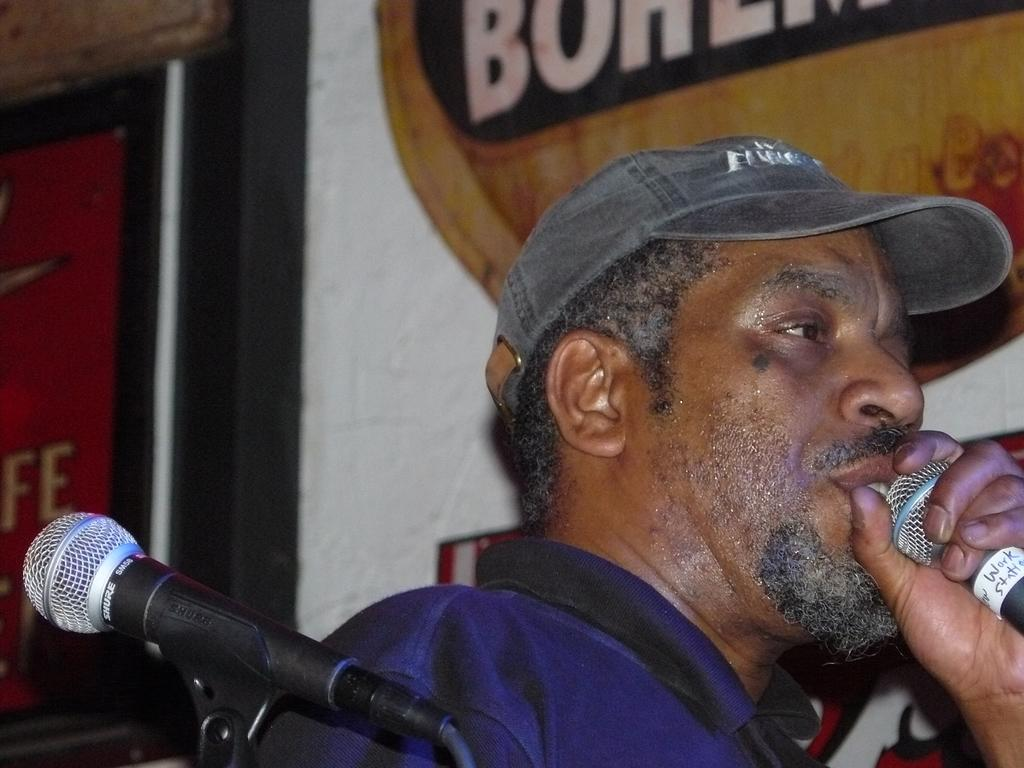Who is present in the image? There is a person in the image. What is the person holding in the image? The person is holding a microphone. What type of headwear is the person wearing? The person is wearing a cap. Can you describe the microphone's location in the image? There is a microphone in the left bottom of the image. What else can be seen in the image besides the person and the microphone? There is a banner in the image. What is visible in the background of the image? There is a wall in the background of the image. What type of linen is being used to clean the microphone in the image? There is no linen present in the image, nor is there any indication that the microphone is being cleaned. 